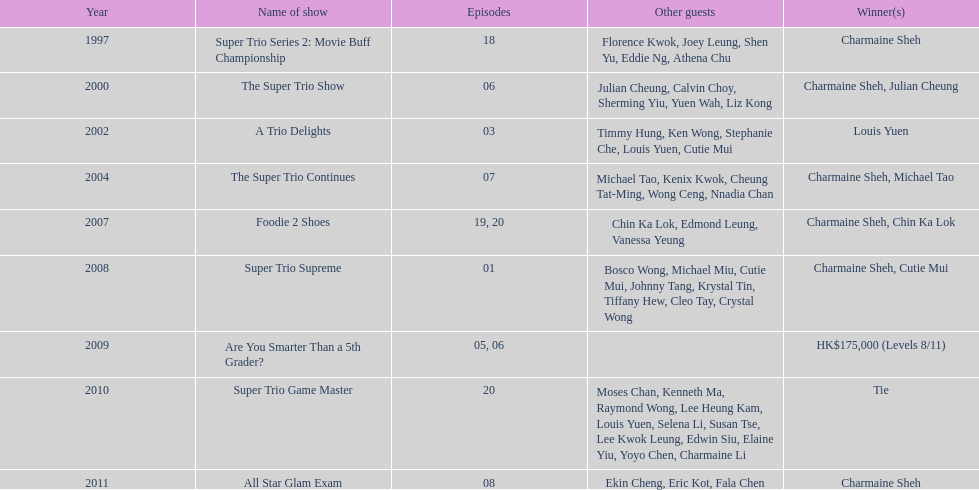What is the number of other guests in the 2002 show "a trio delights"? 5. 